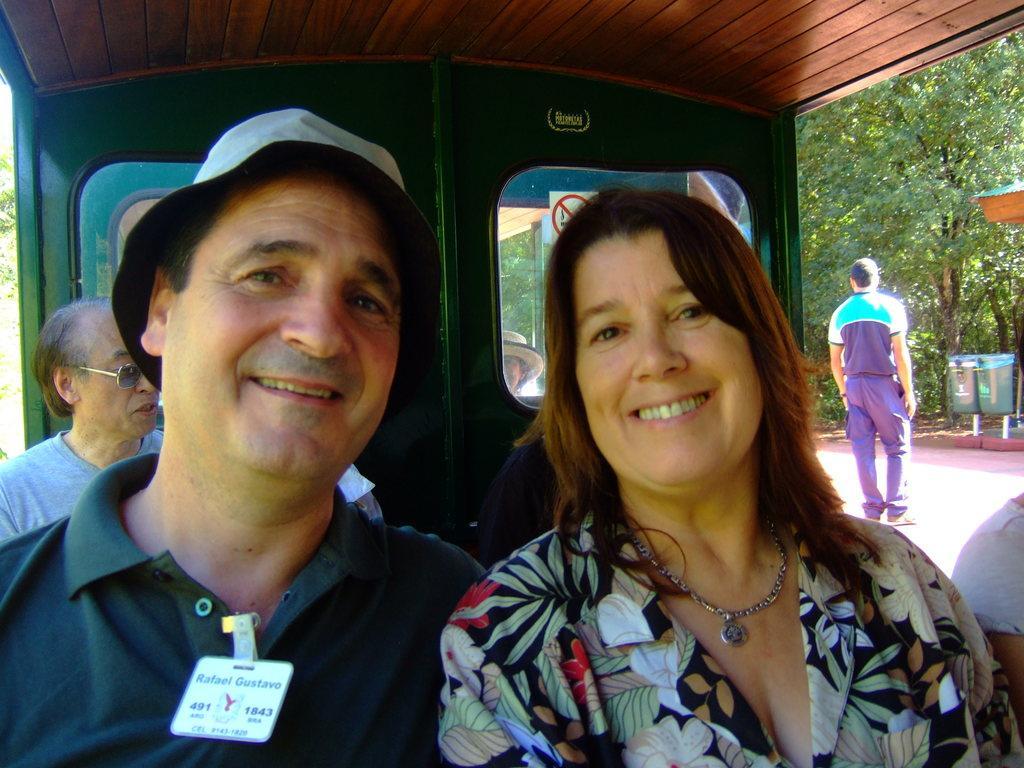How would you summarize this image in a sentence or two? Here I can see few people sitting in a vehicle. In the foreground a man and woman are smiling and giving pose for the picture. On the right side there is a person standing on the floor. In the background there are trees and also there are two dustbins. 